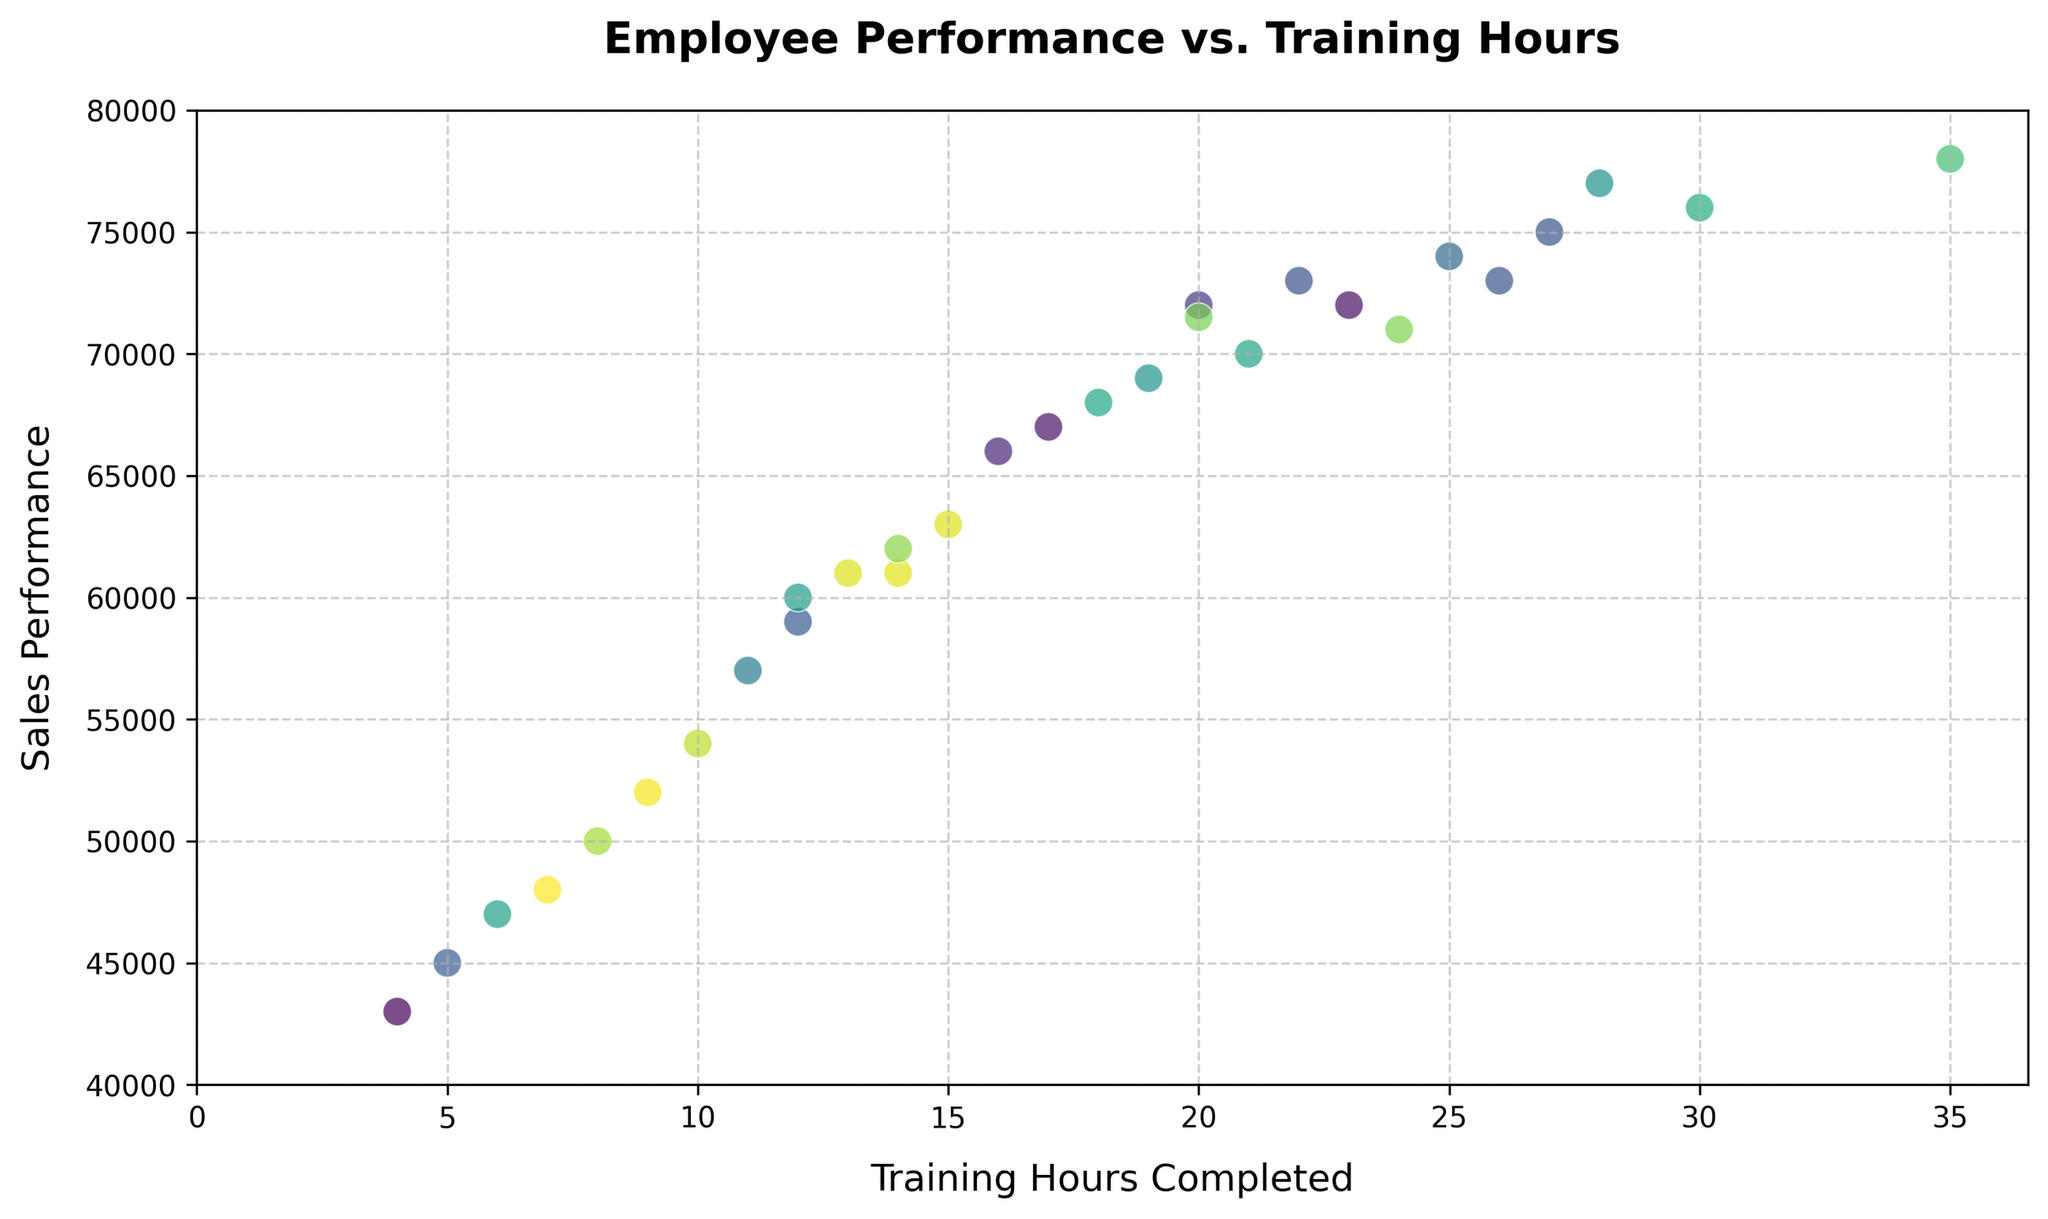What is the relationship between training hours and sales performance? To identify the relationship, one can observe the scatter plot pattern. More concentrated points from the bottom-left to the top-right suggest a positive relationship, indicating that higher training hours generally result in higher sales performance.
Answer: Positive relationship Which employee has the highest sales performance? The highest sales value in the plot appears to be 78000. By checking the data, Employee E012 has a sales performance of 78000.
Answer: E012 How many employees have sales performance below 50000? Locate points below the 50000 sales performance line and count them. Employees with IDs E007, E013, E022, and E029 fall into this category.
Answer: 4 Is there any employee with more than 30 training hours? Observing the x-axis, look for points at or beyond the 30-hour mark. Employee E012 has completed 35 training hours.
Answer: Yes, E012 Which two employees have the closest sales performance values, and what are those values? Identify the closest points vertically. Employees E009 and E023 both show sales performances of 61000.
Answer: E009 and E023, both 61000 Identify the employees with the least training hours and their sales performance. Locate the point at the smallest x-value, which is 4 hours. Employee E029 has a performance of 43000.
Answer: E029, 43000 Compare the sales performance of employees E008 and E016. Who performs better, and what is the difference in their performances? Inspect points corresponding to E008 and E016. E008 has 66000, while E016 has 60000. Compute the difference, which is 66000 - 60000 = 6000.
Answer: E008 performs better by 6000 What is the average sales performance of employees with more than 25 training hours? Identify employees with more than 25 training hours (E012, E017, E025). Their sales performances are 78000, 75000, and 77000. Calculate the average: (78000 + 75000 + 77000) / 3 = 76666.67.
Answer: 76666.67 How many employees completed between 10 and 20 training hours? Count points between 10 and 20 on the x-axis. Employees E001, E003, E005, E008, E009, E011, E016, E018, E019, E020, E024, E030 fall within this range.
Answer: 12 If an employee wants to achieve at least 70000 in sales performance, what is the minimum training hours observed in the data to reach this goal? Identify the points with sales performance of at least 70000 and find the minimum x-value. Observing the plot, E010 has 22 hours for this sales performance.
Answer: 22 